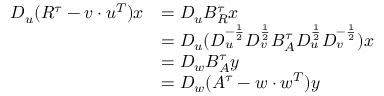Convert formula to latex. <formula><loc_0><loc_0><loc_500><loc_500>\begin{array} { r l } { D _ { u } ( R ^ { \tau } - v \cdot u ^ { T } ) x } & { = D _ { u } B _ { R } ^ { \tau } x } \\ & { = D _ { u } ( D _ { u } ^ { - \frac { 1 } { 2 } } D _ { v } ^ { \frac { 1 } { 2 } } B _ { A } ^ { \tau } D _ { u } ^ { \frac { 1 } { 2 } } D _ { v } ^ { - \frac { 1 } { 2 } } ) x } \\ & { = D _ { w } B _ { A } ^ { \tau } y } \\ & { = D _ { w } ( A ^ { \tau } - w \cdot w ^ { T } ) y } \end{array}</formula> 